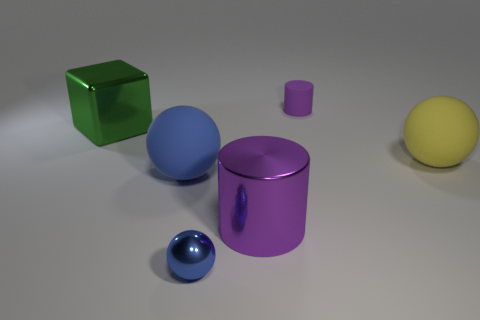Are there any other large cubes of the same color as the block?
Offer a very short reply. No. How many small purple matte cylinders are behind the big shiny thing in front of the large green thing?
Your response must be concise. 1. Are there more yellow rubber cylinders than big green blocks?
Offer a very short reply. No. Does the big blue sphere have the same material as the tiny purple thing?
Provide a short and direct response. Yes. Is the number of tiny objects that are to the right of the purple rubber cylinder the same as the number of large blue objects?
Provide a succinct answer. No. What number of green blocks have the same material as the large purple cylinder?
Give a very brief answer. 1. Are there fewer small blue objects than matte spheres?
Your answer should be compact. Yes. Is the color of the big ball to the left of the blue metal thing the same as the metal cylinder?
Your answer should be very brief. No. There is a purple cylinder that is in front of the matte object to the left of the purple matte cylinder; how many small things are in front of it?
Your answer should be very brief. 1. There is a small blue object; what number of objects are behind it?
Offer a terse response. 5. 